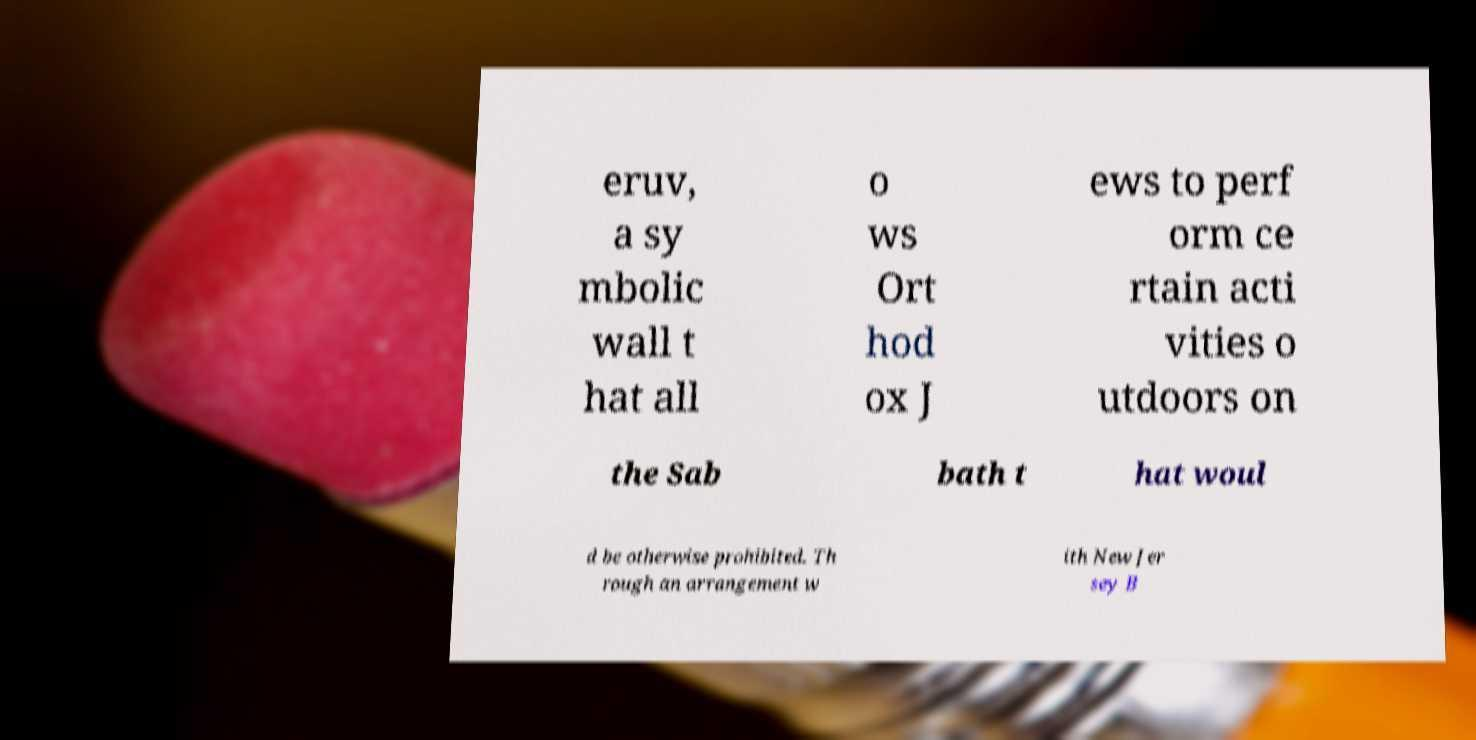Can you read and provide the text displayed in the image?This photo seems to have some interesting text. Can you extract and type it out for me? eruv, a sy mbolic wall t hat all o ws Ort hod ox J ews to perf orm ce rtain acti vities o utdoors on the Sab bath t hat woul d be otherwise prohibited. Th rough an arrangement w ith New Jer sey B 